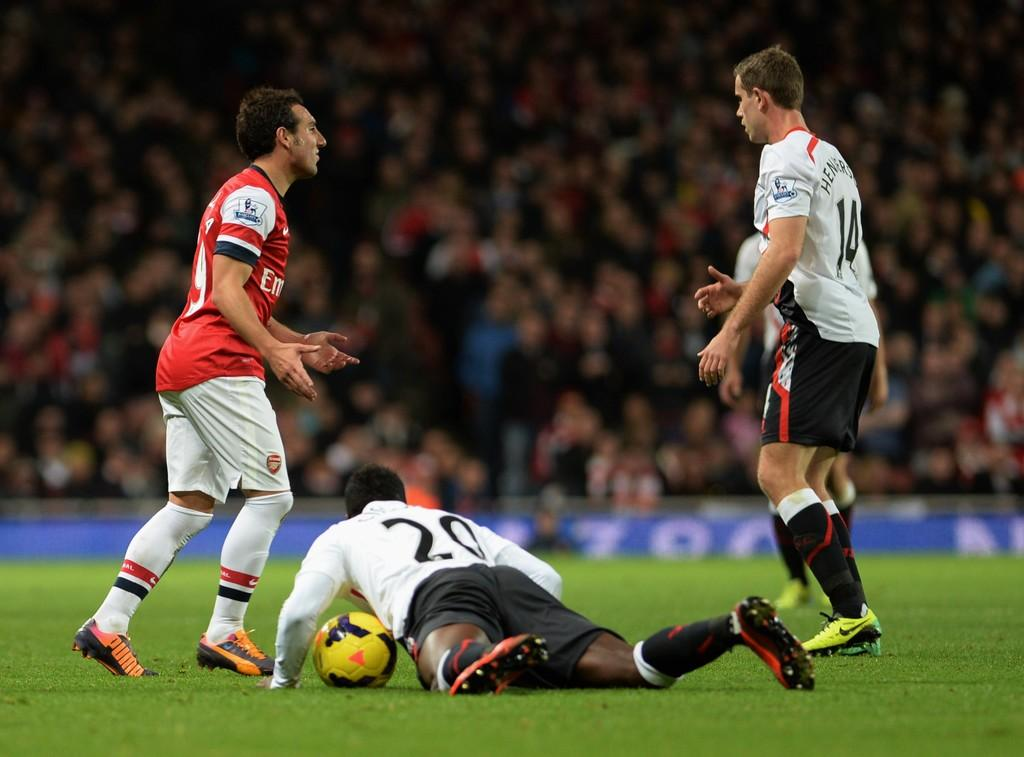What activity is taking place in the image? Players are playing on a ground in the image. Can you describe the condition of one of the players? One player is laying on the ground. What object is near the player on the ground? There is a football beside the player. How would you describe the background of the image? The background of the image is blurred. What type of oven is being used to cook the players in the image? There is no oven present in the image, and the players are not being cooked. 